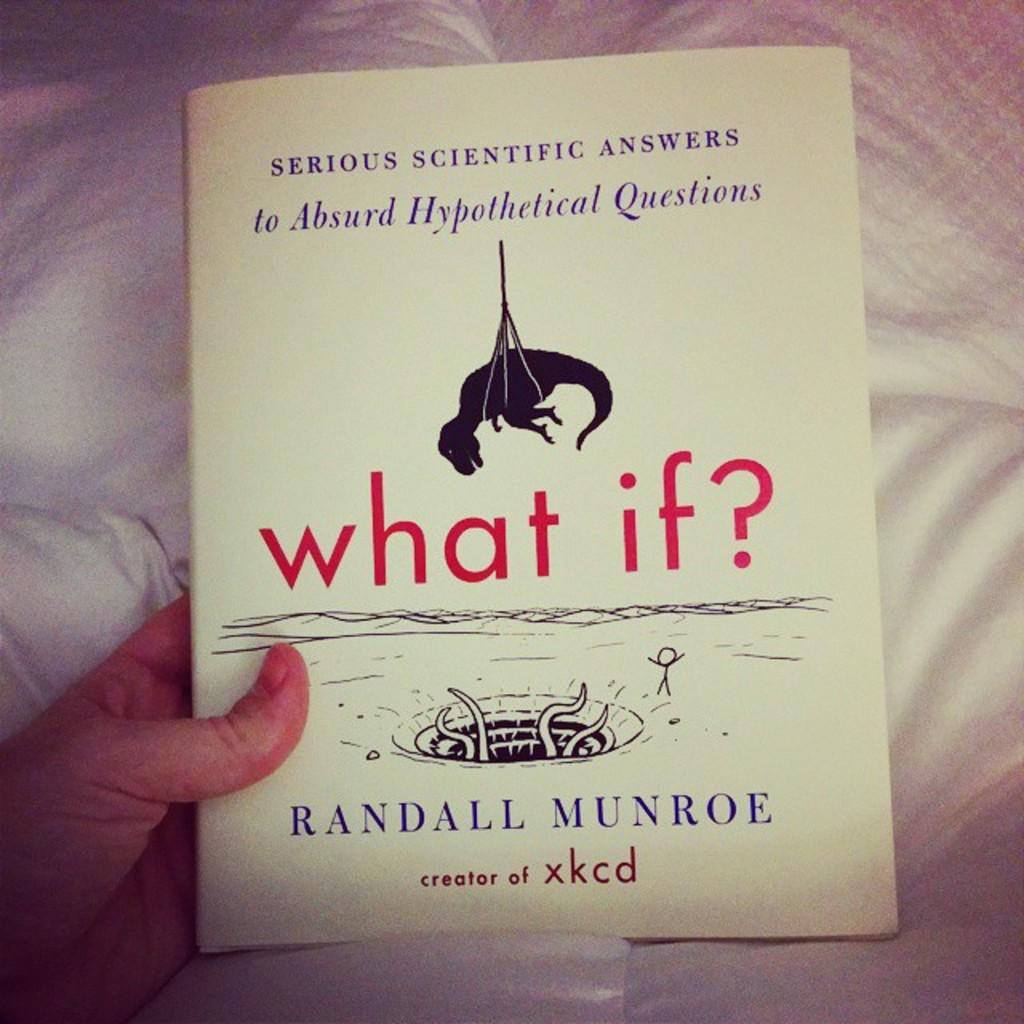What is the title of the book?
Offer a very short reply. What if?. Who is the author?
Your answer should be very brief. Randall munroe. 